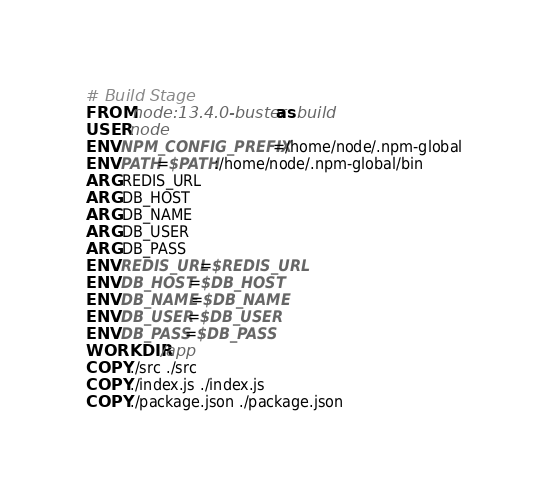Convert code to text. <code><loc_0><loc_0><loc_500><loc_500><_Dockerfile_># Build Stage
FROM node:13.4.0-buster as build
USER node
ENV NPM_CONFIG_PREFIX=/home/node/.npm-global
ENV PATH=$PATH:/home/node/.npm-global/bin
ARG REDIS_URL
ARG DB_HOST
ARG DB_NAME
ARG DB_USER
ARG DB_PASS
ENV REDIS_URL=$REDIS_URL
ENV DB_HOST=$DB_HOST
ENV DB_NAME=$DB_NAME
ENV DB_USER=$DB_USER
ENV DB_PASS=$DB_PASS
WORKDIR /app
COPY ./src ./src
COPY ./index.js ./index.js
COPY ./package.json ./package.json</code> 